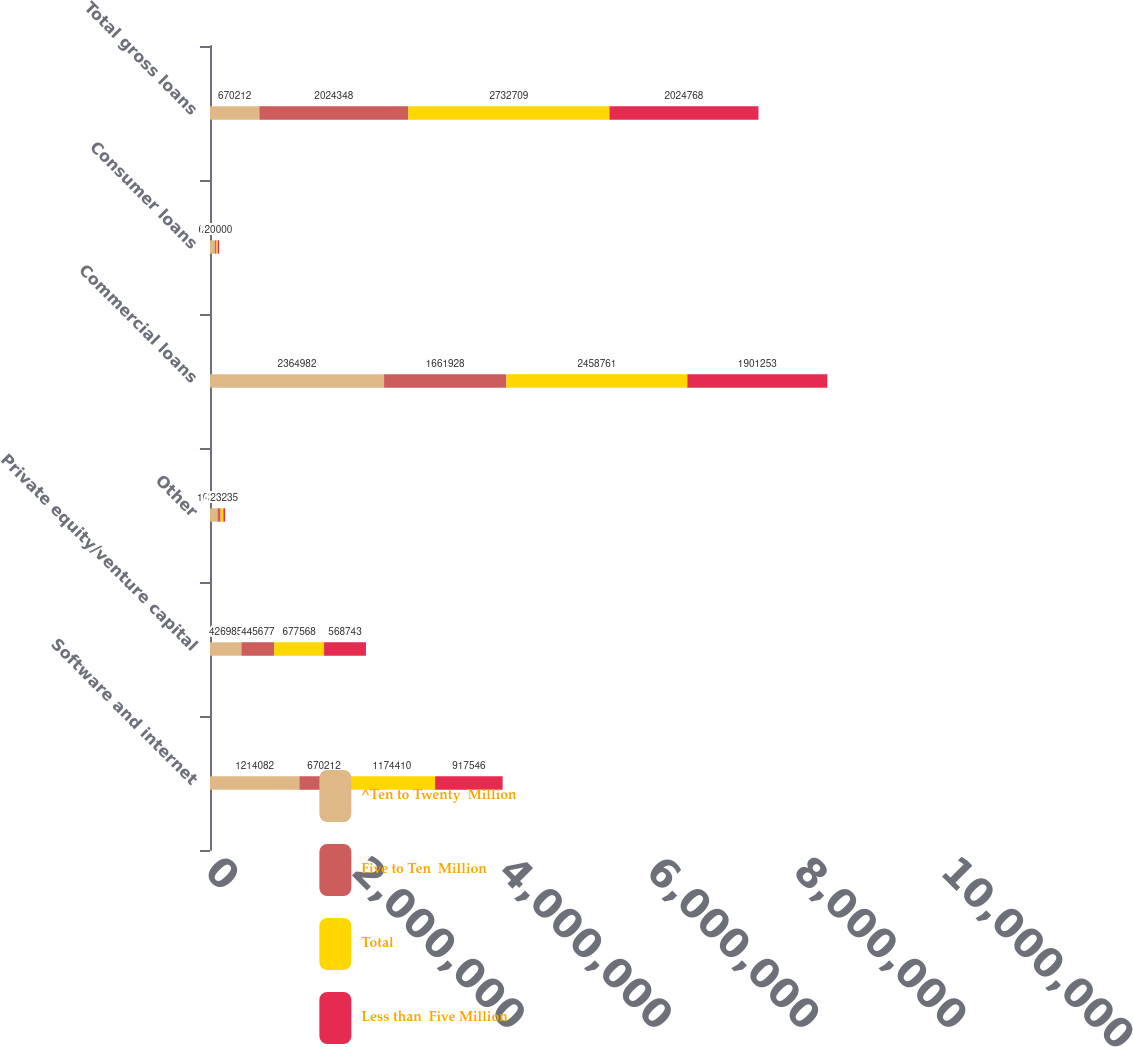<chart> <loc_0><loc_0><loc_500><loc_500><stacked_bar_chart><ecel><fcel>Software and internet<fcel>Private equity/venture capital<fcel>Other<fcel>Commercial loans<fcel>Consumer loans<fcel>Total gross loans<nl><fcel>^Ten to Twenty  Million<fcel>1.21408e+06<fcel>426985<fcel>101779<fcel>2.36498e+06<fcel>65326<fcel>670212<nl><fcel>Five to Ten  Million<fcel>670212<fcel>445677<fcel>42906<fcel>1.66193e+06<fcel>22593<fcel>2.02435e+06<nl><fcel>Total<fcel>1.17441e+06<fcel>677568<fcel>36904<fcel>2.45876e+06<fcel>16418<fcel>2.73271e+06<nl><fcel>Less than  Five Million<fcel>917546<fcel>568743<fcel>23235<fcel>1.90125e+06<fcel>20000<fcel>2.02477e+06<nl></chart> 